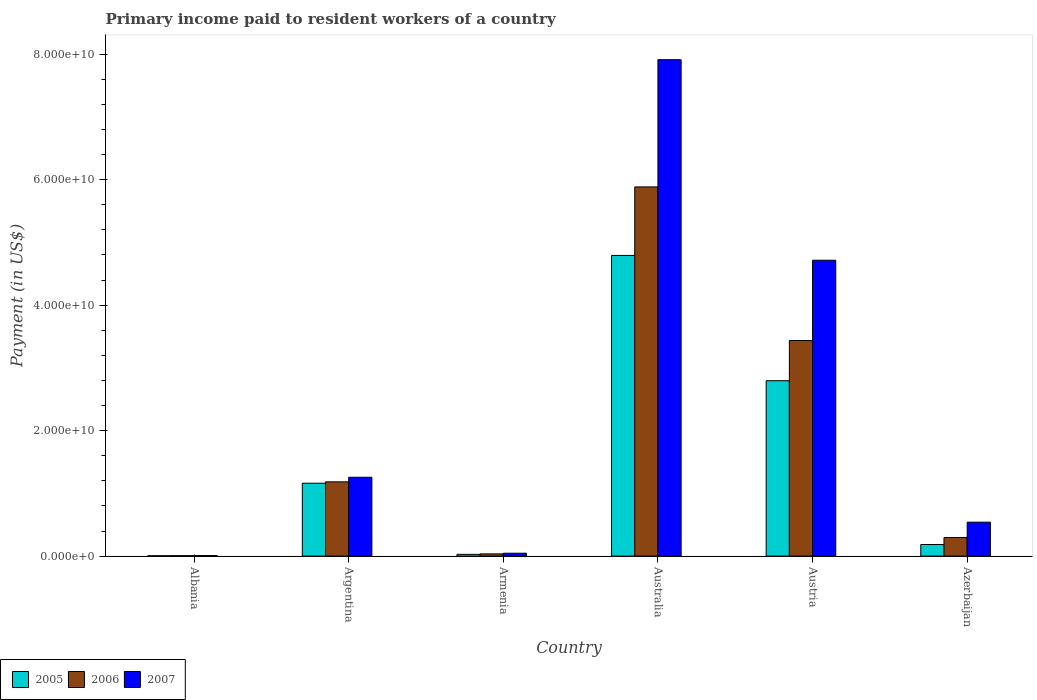Are the number of bars per tick equal to the number of legend labels?
Offer a terse response. Yes. How many bars are there on the 5th tick from the left?
Provide a short and direct response. 3. How many bars are there on the 6th tick from the right?
Ensure brevity in your answer.  3. What is the label of the 5th group of bars from the left?
Provide a succinct answer. Austria. What is the amount paid to workers in 2005 in Azerbaijan?
Make the answer very short. 1.85e+09. Across all countries, what is the maximum amount paid to workers in 2006?
Your answer should be compact. 5.88e+1. Across all countries, what is the minimum amount paid to workers in 2007?
Offer a very short reply. 8.51e+07. In which country was the amount paid to workers in 2005 minimum?
Your answer should be very brief. Albania. What is the total amount paid to workers in 2005 in the graph?
Your answer should be very brief. 8.97e+1. What is the difference between the amount paid to workers in 2007 in Albania and that in Armenia?
Give a very brief answer. -3.74e+08. What is the difference between the amount paid to workers in 2005 in Australia and the amount paid to workers in 2006 in Azerbaijan?
Provide a short and direct response. 4.50e+1. What is the average amount paid to workers in 2006 per country?
Your response must be concise. 1.81e+1. What is the difference between the amount paid to workers of/in 2005 and amount paid to workers of/in 2006 in Austria?
Offer a terse response. -6.40e+09. In how many countries, is the amount paid to workers in 2005 greater than 68000000000 US$?
Ensure brevity in your answer.  0. What is the ratio of the amount paid to workers in 2007 in Australia to that in Azerbaijan?
Provide a succinct answer. 14.63. Is the amount paid to workers in 2006 in Armenia less than that in Australia?
Provide a succinct answer. Yes. What is the difference between the highest and the second highest amount paid to workers in 2006?
Make the answer very short. -2.45e+1. What is the difference between the highest and the lowest amount paid to workers in 2007?
Make the answer very short. 7.90e+1. What is the difference between two consecutive major ticks on the Y-axis?
Keep it short and to the point. 2.00e+1. Are the values on the major ticks of Y-axis written in scientific E-notation?
Your response must be concise. Yes. Does the graph contain grids?
Offer a terse response. No. How many legend labels are there?
Offer a terse response. 3. What is the title of the graph?
Offer a very short reply. Primary income paid to resident workers of a country. Does "1990" appear as one of the legend labels in the graph?
Your response must be concise. No. What is the label or title of the Y-axis?
Your answer should be compact. Payment (in US$). What is the Payment (in US$) of 2005 in Albania?
Make the answer very short. 5.26e+07. What is the Payment (in US$) of 2006 in Albania?
Provide a short and direct response. 6.91e+07. What is the Payment (in US$) of 2007 in Albania?
Your response must be concise. 8.51e+07. What is the Payment (in US$) in 2005 in Argentina?
Keep it short and to the point. 1.16e+1. What is the Payment (in US$) in 2006 in Argentina?
Your answer should be compact. 1.18e+1. What is the Payment (in US$) of 2007 in Argentina?
Ensure brevity in your answer.  1.26e+1. What is the Payment (in US$) in 2005 in Armenia?
Offer a very short reply. 2.79e+08. What is the Payment (in US$) of 2006 in Armenia?
Keep it short and to the point. 3.54e+08. What is the Payment (in US$) of 2007 in Armenia?
Provide a short and direct response. 4.59e+08. What is the Payment (in US$) in 2005 in Australia?
Offer a very short reply. 4.79e+1. What is the Payment (in US$) in 2006 in Australia?
Ensure brevity in your answer.  5.88e+1. What is the Payment (in US$) in 2007 in Australia?
Offer a terse response. 7.91e+1. What is the Payment (in US$) of 2005 in Austria?
Ensure brevity in your answer.  2.80e+1. What is the Payment (in US$) in 2006 in Austria?
Provide a succinct answer. 3.44e+1. What is the Payment (in US$) of 2007 in Austria?
Keep it short and to the point. 4.72e+1. What is the Payment (in US$) in 2005 in Azerbaijan?
Provide a succinct answer. 1.85e+09. What is the Payment (in US$) of 2006 in Azerbaijan?
Provide a short and direct response. 2.96e+09. What is the Payment (in US$) in 2007 in Azerbaijan?
Provide a short and direct response. 5.41e+09. Across all countries, what is the maximum Payment (in US$) of 2005?
Your answer should be compact. 4.79e+1. Across all countries, what is the maximum Payment (in US$) of 2006?
Keep it short and to the point. 5.88e+1. Across all countries, what is the maximum Payment (in US$) in 2007?
Ensure brevity in your answer.  7.91e+1. Across all countries, what is the minimum Payment (in US$) in 2005?
Provide a succinct answer. 5.26e+07. Across all countries, what is the minimum Payment (in US$) in 2006?
Ensure brevity in your answer.  6.91e+07. Across all countries, what is the minimum Payment (in US$) of 2007?
Your answer should be compact. 8.51e+07. What is the total Payment (in US$) of 2005 in the graph?
Provide a succinct answer. 8.97e+1. What is the total Payment (in US$) in 2006 in the graph?
Your response must be concise. 1.08e+11. What is the total Payment (in US$) of 2007 in the graph?
Ensure brevity in your answer.  1.45e+11. What is the difference between the Payment (in US$) of 2005 in Albania and that in Argentina?
Give a very brief answer. -1.16e+1. What is the difference between the Payment (in US$) in 2006 in Albania and that in Argentina?
Make the answer very short. -1.18e+1. What is the difference between the Payment (in US$) in 2007 in Albania and that in Argentina?
Offer a very short reply. -1.25e+1. What is the difference between the Payment (in US$) of 2005 in Albania and that in Armenia?
Make the answer very short. -2.26e+08. What is the difference between the Payment (in US$) in 2006 in Albania and that in Armenia?
Ensure brevity in your answer.  -2.85e+08. What is the difference between the Payment (in US$) of 2007 in Albania and that in Armenia?
Offer a terse response. -3.74e+08. What is the difference between the Payment (in US$) in 2005 in Albania and that in Australia?
Give a very brief answer. -4.79e+1. What is the difference between the Payment (in US$) in 2006 in Albania and that in Australia?
Keep it short and to the point. -5.88e+1. What is the difference between the Payment (in US$) in 2007 in Albania and that in Australia?
Your answer should be very brief. -7.90e+1. What is the difference between the Payment (in US$) in 2005 in Albania and that in Austria?
Ensure brevity in your answer.  -2.79e+1. What is the difference between the Payment (in US$) in 2006 in Albania and that in Austria?
Offer a terse response. -3.43e+1. What is the difference between the Payment (in US$) in 2007 in Albania and that in Austria?
Make the answer very short. -4.71e+1. What is the difference between the Payment (in US$) of 2005 in Albania and that in Azerbaijan?
Give a very brief answer. -1.79e+09. What is the difference between the Payment (in US$) in 2006 in Albania and that in Azerbaijan?
Your answer should be compact. -2.89e+09. What is the difference between the Payment (in US$) of 2007 in Albania and that in Azerbaijan?
Offer a very short reply. -5.32e+09. What is the difference between the Payment (in US$) of 2005 in Argentina and that in Armenia?
Make the answer very short. 1.13e+1. What is the difference between the Payment (in US$) of 2006 in Argentina and that in Armenia?
Offer a terse response. 1.15e+1. What is the difference between the Payment (in US$) of 2007 in Argentina and that in Armenia?
Your answer should be compact. 1.21e+1. What is the difference between the Payment (in US$) of 2005 in Argentina and that in Australia?
Provide a short and direct response. -3.63e+1. What is the difference between the Payment (in US$) of 2006 in Argentina and that in Australia?
Keep it short and to the point. -4.70e+1. What is the difference between the Payment (in US$) of 2007 in Argentina and that in Australia?
Provide a short and direct response. -6.66e+1. What is the difference between the Payment (in US$) in 2005 in Argentina and that in Austria?
Offer a very short reply. -1.63e+1. What is the difference between the Payment (in US$) in 2006 in Argentina and that in Austria?
Your answer should be compact. -2.25e+1. What is the difference between the Payment (in US$) in 2007 in Argentina and that in Austria?
Offer a very short reply. -3.46e+1. What is the difference between the Payment (in US$) of 2005 in Argentina and that in Azerbaijan?
Keep it short and to the point. 9.77e+09. What is the difference between the Payment (in US$) of 2006 in Argentina and that in Azerbaijan?
Your answer should be very brief. 8.87e+09. What is the difference between the Payment (in US$) in 2007 in Argentina and that in Azerbaijan?
Your answer should be very brief. 7.16e+09. What is the difference between the Payment (in US$) in 2005 in Armenia and that in Australia?
Give a very brief answer. -4.76e+1. What is the difference between the Payment (in US$) of 2006 in Armenia and that in Australia?
Keep it short and to the point. -5.85e+1. What is the difference between the Payment (in US$) in 2007 in Armenia and that in Australia?
Your answer should be compact. -7.87e+1. What is the difference between the Payment (in US$) in 2005 in Armenia and that in Austria?
Provide a short and direct response. -2.77e+1. What is the difference between the Payment (in US$) of 2006 in Armenia and that in Austria?
Ensure brevity in your answer.  -3.40e+1. What is the difference between the Payment (in US$) in 2007 in Armenia and that in Austria?
Your answer should be very brief. -4.67e+1. What is the difference between the Payment (in US$) of 2005 in Armenia and that in Azerbaijan?
Your response must be concise. -1.57e+09. What is the difference between the Payment (in US$) of 2006 in Armenia and that in Azerbaijan?
Offer a terse response. -2.61e+09. What is the difference between the Payment (in US$) of 2007 in Armenia and that in Azerbaijan?
Your answer should be compact. -4.95e+09. What is the difference between the Payment (in US$) in 2005 in Australia and that in Austria?
Give a very brief answer. 2.00e+1. What is the difference between the Payment (in US$) in 2006 in Australia and that in Austria?
Offer a terse response. 2.45e+1. What is the difference between the Payment (in US$) in 2007 in Australia and that in Austria?
Your response must be concise. 3.20e+1. What is the difference between the Payment (in US$) of 2005 in Australia and that in Azerbaijan?
Give a very brief answer. 4.61e+1. What is the difference between the Payment (in US$) of 2006 in Australia and that in Azerbaijan?
Keep it short and to the point. 5.59e+1. What is the difference between the Payment (in US$) in 2007 in Australia and that in Azerbaijan?
Give a very brief answer. 7.37e+1. What is the difference between the Payment (in US$) of 2005 in Austria and that in Azerbaijan?
Make the answer very short. 2.61e+1. What is the difference between the Payment (in US$) of 2006 in Austria and that in Azerbaijan?
Ensure brevity in your answer.  3.14e+1. What is the difference between the Payment (in US$) of 2007 in Austria and that in Azerbaijan?
Offer a very short reply. 4.18e+1. What is the difference between the Payment (in US$) in 2005 in Albania and the Payment (in US$) in 2006 in Argentina?
Offer a very short reply. -1.18e+1. What is the difference between the Payment (in US$) of 2005 in Albania and the Payment (in US$) of 2007 in Argentina?
Give a very brief answer. -1.25e+1. What is the difference between the Payment (in US$) of 2006 in Albania and the Payment (in US$) of 2007 in Argentina?
Keep it short and to the point. -1.25e+1. What is the difference between the Payment (in US$) of 2005 in Albania and the Payment (in US$) of 2006 in Armenia?
Keep it short and to the point. -3.01e+08. What is the difference between the Payment (in US$) of 2005 in Albania and the Payment (in US$) of 2007 in Armenia?
Offer a terse response. -4.06e+08. What is the difference between the Payment (in US$) of 2006 in Albania and the Payment (in US$) of 2007 in Armenia?
Offer a terse response. -3.90e+08. What is the difference between the Payment (in US$) in 2005 in Albania and the Payment (in US$) in 2006 in Australia?
Offer a very short reply. -5.88e+1. What is the difference between the Payment (in US$) of 2005 in Albania and the Payment (in US$) of 2007 in Australia?
Ensure brevity in your answer.  -7.91e+1. What is the difference between the Payment (in US$) of 2006 in Albania and the Payment (in US$) of 2007 in Australia?
Your response must be concise. -7.91e+1. What is the difference between the Payment (in US$) of 2005 in Albania and the Payment (in US$) of 2006 in Austria?
Your answer should be compact. -3.43e+1. What is the difference between the Payment (in US$) of 2005 in Albania and the Payment (in US$) of 2007 in Austria?
Your answer should be very brief. -4.71e+1. What is the difference between the Payment (in US$) of 2006 in Albania and the Payment (in US$) of 2007 in Austria?
Give a very brief answer. -4.71e+1. What is the difference between the Payment (in US$) of 2005 in Albania and the Payment (in US$) of 2006 in Azerbaijan?
Give a very brief answer. -2.91e+09. What is the difference between the Payment (in US$) in 2005 in Albania and the Payment (in US$) in 2007 in Azerbaijan?
Offer a terse response. -5.35e+09. What is the difference between the Payment (in US$) in 2006 in Albania and the Payment (in US$) in 2007 in Azerbaijan?
Your answer should be compact. -5.34e+09. What is the difference between the Payment (in US$) of 2005 in Argentina and the Payment (in US$) of 2006 in Armenia?
Provide a short and direct response. 1.13e+1. What is the difference between the Payment (in US$) in 2005 in Argentina and the Payment (in US$) in 2007 in Armenia?
Offer a terse response. 1.12e+1. What is the difference between the Payment (in US$) of 2006 in Argentina and the Payment (in US$) of 2007 in Armenia?
Provide a succinct answer. 1.14e+1. What is the difference between the Payment (in US$) in 2005 in Argentina and the Payment (in US$) in 2006 in Australia?
Make the answer very short. -4.72e+1. What is the difference between the Payment (in US$) in 2005 in Argentina and the Payment (in US$) in 2007 in Australia?
Make the answer very short. -6.75e+1. What is the difference between the Payment (in US$) in 2006 in Argentina and the Payment (in US$) in 2007 in Australia?
Your answer should be compact. -6.73e+1. What is the difference between the Payment (in US$) in 2005 in Argentina and the Payment (in US$) in 2006 in Austria?
Offer a terse response. -2.27e+1. What is the difference between the Payment (in US$) of 2005 in Argentina and the Payment (in US$) of 2007 in Austria?
Keep it short and to the point. -3.55e+1. What is the difference between the Payment (in US$) in 2006 in Argentina and the Payment (in US$) in 2007 in Austria?
Offer a very short reply. -3.53e+1. What is the difference between the Payment (in US$) in 2005 in Argentina and the Payment (in US$) in 2006 in Azerbaijan?
Make the answer very short. 8.66e+09. What is the difference between the Payment (in US$) in 2005 in Argentina and the Payment (in US$) in 2007 in Azerbaijan?
Make the answer very short. 6.21e+09. What is the difference between the Payment (in US$) of 2006 in Argentina and the Payment (in US$) of 2007 in Azerbaijan?
Offer a terse response. 6.43e+09. What is the difference between the Payment (in US$) of 2005 in Armenia and the Payment (in US$) of 2006 in Australia?
Your answer should be compact. -5.86e+1. What is the difference between the Payment (in US$) in 2005 in Armenia and the Payment (in US$) in 2007 in Australia?
Provide a short and direct response. -7.88e+1. What is the difference between the Payment (in US$) of 2006 in Armenia and the Payment (in US$) of 2007 in Australia?
Provide a short and direct response. -7.88e+1. What is the difference between the Payment (in US$) of 2005 in Armenia and the Payment (in US$) of 2006 in Austria?
Offer a terse response. -3.41e+1. What is the difference between the Payment (in US$) of 2005 in Armenia and the Payment (in US$) of 2007 in Austria?
Offer a terse response. -4.69e+1. What is the difference between the Payment (in US$) in 2006 in Armenia and the Payment (in US$) in 2007 in Austria?
Your answer should be very brief. -4.68e+1. What is the difference between the Payment (in US$) in 2005 in Armenia and the Payment (in US$) in 2006 in Azerbaijan?
Make the answer very short. -2.68e+09. What is the difference between the Payment (in US$) in 2005 in Armenia and the Payment (in US$) in 2007 in Azerbaijan?
Offer a terse response. -5.13e+09. What is the difference between the Payment (in US$) in 2006 in Armenia and the Payment (in US$) in 2007 in Azerbaijan?
Provide a short and direct response. -5.05e+09. What is the difference between the Payment (in US$) in 2005 in Australia and the Payment (in US$) in 2006 in Austria?
Make the answer very short. 1.36e+1. What is the difference between the Payment (in US$) in 2005 in Australia and the Payment (in US$) in 2007 in Austria?
Provide a succinct answer. 7.68e+08. What is the difference between the Payment (in US$) in 2006 in Australia and the Payment (in US$) in 2007 in Austria?
Offer a very short reply. 1.17e+1. What is the difference between the Payment (in US$) of 2005 in Australia and the Payment (in US$) of 2006 in Azerbaijan?
Your answer should be compact. 4.50e+1. What is the difference between the Payment (in US$) of 2005 in Australia and the Payment (in US$) of 2007 in Azerbaijan?
Offer a very short reply. 4.25e+1. What is the difference between the Payment (in US$) in 2006 in Australia and the Payment (in US$) in 2007 in Azerbaijan?
Offer a terse response. 5.34e+1. What is the difference between the Payment (in US$) of 2005 in Austria and the Payment (in US$) of 2006 in Azerbaijan?
Make the answer very short. 2.50e+1. What is the difference between the Payment (in US$) in 2005 in Austria and the Payment (in US$) in 2007 in Azerbaijan?
Offer a very short reply. 2.25e+1. What is the difference between the Payment (in US$) of 2006 in Austria and the Payment (in US$) of 2007 in Azerbaijan?
Keep it short and to the point. 2.90e+1. What is the average Payment (in US$) in 2005 per country?
Provide a succinct answer. 1.49e+1. What is the average Payment (in US$) in 2006 per country?
Keep it short and to the point. 1.81e+1. What is the average Payment (in US$) in 2007 per country?
Give a very brief answer. 2.41e+1. What is the difference between the Payment (in US$) of 2005 and Payment (in US$) of 2006 in Albania?
Offer a terse response. -1.65e+07. What is the difference between the Payment (in US$) of 2005 and Payment (in US$) of 2007 in Albania?
Ensure brevity in your answer.  -3.25e+07. What is the difference between the Payment (in US$) in 2006 and Payment (in US$) in 2007 in Albania?
Your answer should be compact. -1.60e+07. What is the difference between the Payment (in US$) of 2005 and Payment (in US$) of 2006 in Argentina?
Provide a short and direct response. -2.18e+08. What is the difference between the Payment (in US$) of 2005 and Payment (in US$) of 2007 in Argentina?
Make the answer very short. -9.50e+08. What is the difference between the Payment (in US$) in 2006 and Payment (in US$) in 2007 in Argentina?
Your answer should be compact. -7.31e+08. What is the difference between the Payment (in US$) of 2005 and Payment (in US$) of 2006 in Armenia?
Provide a succinct answer. -7.51e+07. What is the difference between the Payment (in US$) of 2005 and Payment (in US$) of 2007 in Armenia?
Offer a terse response. -1.80e+08. What is the difference between the Payment (in US$) of 2006 and Payment (in US$) of 2007 in Armenia?
Your answer should be compact. -1.05e+08. What is the difference between the Payment (in US$) of 2005 and Payment (in US$) of 2006 in Australia?
Provide a short and direct response. -1.09e+1. What is the difference between the Payment (in US$) in 2005 and Payment (in US$) in 2007 in Australia?
Your answer should be very brief. -3.12e+1. What is the difference between the Payment (in US$) of 2006 and Payment (in US$) of 2007 in Australia?
Make the answer very short. -2.03e+1. What is the difference between the Payment (in US$) in 2005 and Payment (in US$) in 2006 in Austria?
Provide a short and direct response. -6.40e+09. What is the difference between the Payment (in US$) of 2005 and Payment (in US$) of 2007 in Austria?
Give a very brief answer. -1.92e+1. What is the difference between the Payment (in US$) in 2006 and Payment (in US$) in 2007 in Austria?
Your answer should be compact. -1.28e+1. What is the difference between the Payment (in US$) in 2005 and Payment (in US$) in 2006 in Azerbaijan?
Offer a terse response. -1.11e+09. What is the difference between the Payment (in US$) of 2005 and Payment (in US$) of 2007 in Azerbaijan?
Your answer should be very brief. -3.56e+09. What is the difference between the Payment (in US$) of 2006 and Payment (in US$) of 2007 in Azerbaijan?
Provide a succinct answer. -2.45e+09. What is the ratio of the Payment (in US$) in 2005 in Albania to that in Argentina?
Your response must be concise. 0. What is the ratio of the Payment (in US$) in 2006 in Albania to that in Argentina?
Provide a succinct answer. 0.01. What is the ratio of the Payment (in US$) in 2007 in Albania to that in Argentina?
Ensure brevity in your answer.  0.01. What is the ratio of the Payment (in US$) in 2005 in Albania to that in Armenia?
Ensure brevity in your answer.  0.19. What is the ratio of the Payment (in US$) in 2006 in Albania to that in Armenia?
Your response must be concise. 0.2. What is the ratio of the Payment (in US$) in 2007 in Albania to that in Armenia?
Give a very brief answer. 0.19. What is the ratio of the Payment (in US$) in 2005 in Albania to that in Australia?
Your answer should be compact. 0. What is the ratio of the Payment (in US$) in 2006 in Albania to that in Australia?
Provide a short and direct response. 0. What is the ratio of the Payment (in US$) of 2007 in Albania to that in Australia?
Provide a short and direct response. 0. What is the ratio of the Payment (in US$) of 2005 in Albania to that in Austria?
Give a very brief answer. 0. What is the ratio of the Payment (in US$) of 2006 in Albania to that in Austria?
Provide a succinct answer. 0. What is the ratio of the Payment (in US$) of 2007 in Albania to that in Austria?
Offer a terse response. 0. What is the ratio of the Payment (in US$) of 2005 in Albania to that in Azerbaijan?
Provide a succinct answer. 0.03. What is the ratio of the Payment (in US$) of 2006 in Albania to that in Azerbaijan?
Provide a short and direct response. 0.02. What is the ratio of the Payment (in US$) of 2007 in Albania to that in Azerbaijan?
Offer a very short reply. 0.02. What is the ratio of the Payment (in US$) in 2005 in Argentina to that in Armenia?
Your answer should be very brief. 41.66. What is the ratio of the Payment (in US$) of 2006 in Argentina to that in Armenia?
Offer a very short reply. 33.44. What is the ratio of the Payment (in US$) in 2007 in Argentina to that in Armenia?
Give a very brief answer. 27.38. What is the ratio of the Payment (in US$) in 2005 in Argentina to that in Australia?
Provide a short and direct response. 0.24. What is the ratio of the Payment (in US$) of 2006 in Argentina to that in Australia?
Offer a terse response. 0.2. What is the ratio of the Payment (in US$) in 2007 in Argentina to that in Australia?
Your response must be concise. 0.16. What is the ratio of the Payment (in US$) of 2005 in Argentina to that in Austria?
Your answer should be very brief. 0.42. What is the ratio of the Payment (in US$) of 2006 in Argentina to that in Austria?
Your answer should be very brief. 0.34. What is the ratio of the Payment (in US$) of 2007 in Argentina to that in Austria?
Offer a very short reply. 0.27. What is the ratio of the Payment (in US$) of 2005 in Argentina to that in Azerbaijan?
Your response must be concise. 6.29. What is the ratio of the Payment (in US$) of 2006 in Argentina to that in Azerbaijan?
Offer a very short reply. 4. What is the ratio of the Payment (in US$) of 2007 in Argentina to that in Azerbaijan?
Your response must be concise. 2.32. What is the ratio of the Payment (in US$) of 2005 in Armenia to that in Australia?
Your answer should be very brief. 0.01. What is the ratio of the Payment (in US$) of 2006 in Armenia to that in Australia?
Offer a very short reply. 0.01. What is the ratio of the Payment (in US$) of 2007 in Armenia to that in Australia?
Give a very brief answer. 0.01. What is the ratio of the Payment (in US$) in 2006 in Armenia to that in Austria?
Offer a terse response. 0.01. What is the ratio of the Payment (in US$) in 2007 in Armenia to that in Austria?
Ensure brevity in your answer.  0.01. What is the ratio of the Payment (in US$) in 2005 in Armenia to that in Azerbaijan?
Keep it short and to the point. 0.15. What is the ratio of the Payment (in US$) in 2006 in Armenia to that in Azerbaijan?
Your response must be concise. 0.12. What is the ratio of the Payment (in US$) of 2007 in Armenia to that in Azerbaijan?
Your response must be concise. 0.08. What is the ratio of the Payment (in US$) in 2005 in Australia to that in Austria?
Your answer should be compact. 1.71. What is the ratio of the Payment (in US$) of 2006 in Australia to that in Austria?
Provide a succinct answer. 1.71. What is the ratio of the Payment (in US$) in 2007 in Australia to that in Austria?
Offer a very short reply. 1.68. What is the ratio of the Payment (in US$) of 2005 in Australia to that in Azerbaijan?
Provide a short and direct response. 25.94. What is the ratio of the Payment (in US$) of 2006 in Australia to that in Azerbaijan?
Provide a succinct answer. 19.88. What is the ratio of the Payment (in US$) in 2007 in Australia to that in Azerbaijan?
Your answer should be very brief. 14.63. What is the ratio of the Payment (in US$) of 2005 in Austria to that in Azerbaijan?
Provide a succinct answer. 15.13. What is the ratio of the Payment (in US$) of 2006 in Austria to that in Azerbaijan?
Offer a terse response. 11.61. What is the ratio of the Payment (in US$) of 2007 in Austria to that in Azerbaijan?
Your answer should be compact. 8.72. What is the difference between the highest and the second highest Payment (in US$) of 2005?
Ensure brevity in your answer.  2.00e+1. What is the difference between the highest and the second highest Payment (in US$) of 2006?
Offer a terse response. 2.45e+1. What is the difference between the highest and the second highest Payment (in US$) of 2007?
Provide a short and direct response. 3.20e+1. What is the difference between the highest and the lowest Payment (in US$) of 2005?
Your response must be concise. 4.79e+1. What is the difference between the highest and the lowest Payment (in US$) in 2006?
Your answer should be compact. 5.88e+1. What is the difference between the highest and the lowest Payment (in US$) of 2007?
Give a very brief answer. 7.90e+1. 